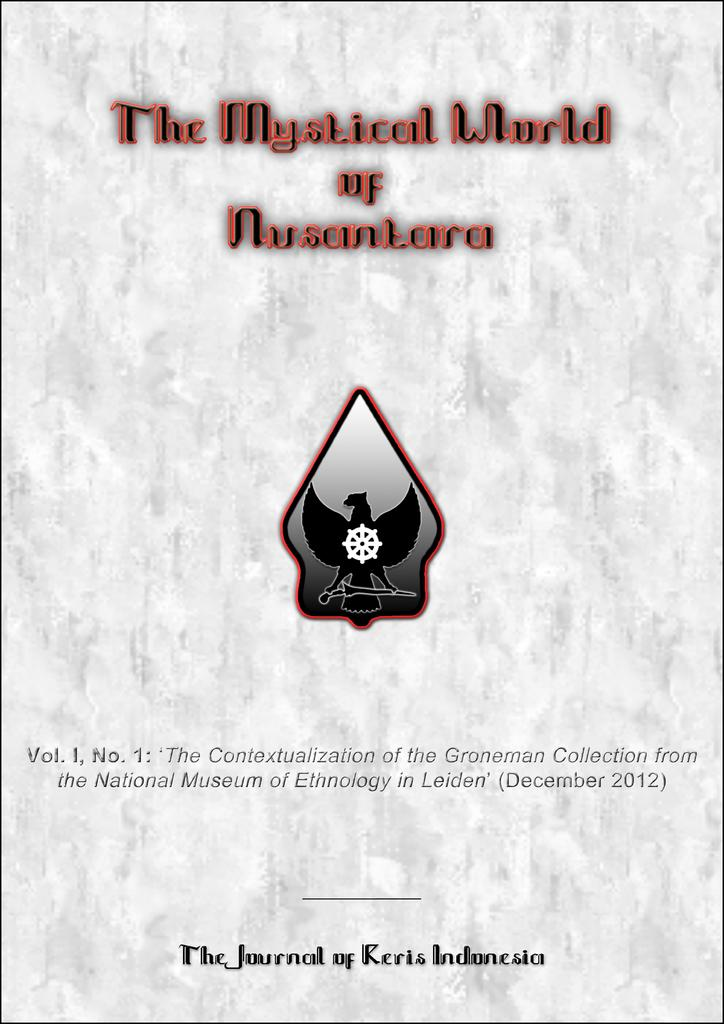<image>
Summarize the visual content of the image. a journal titled the mystical world of nuscantara by journal of keris indonesia. 